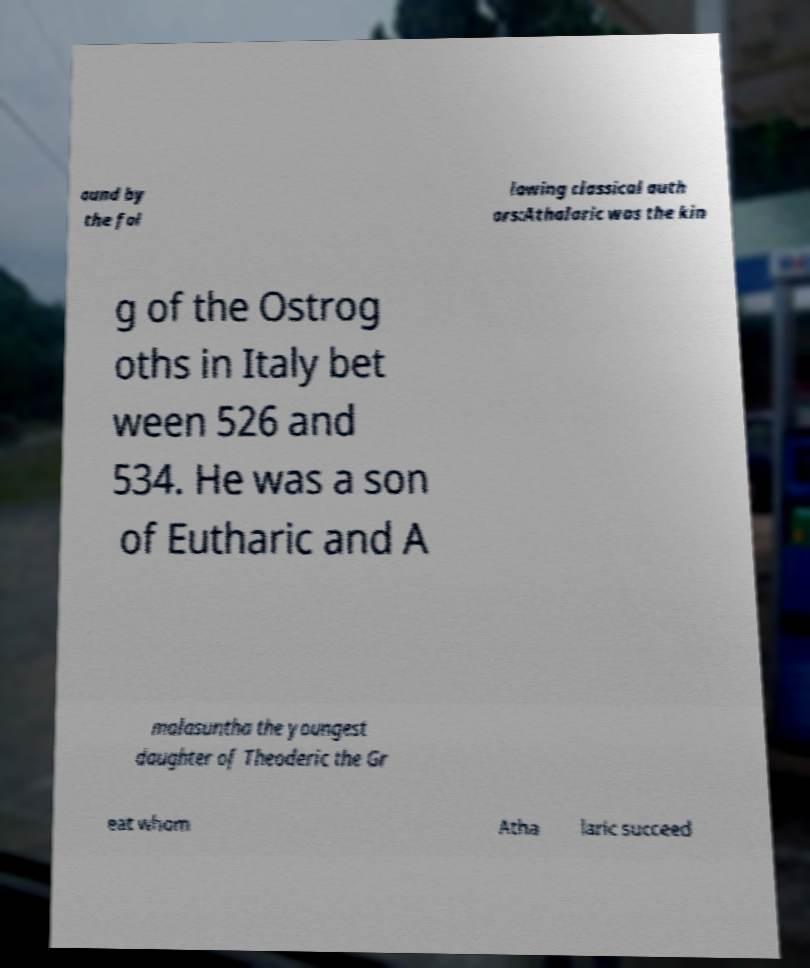For documentation purposes, I need the text within this image transcribed. Could you provide that? ound by the fol lowing classical auth ors:Athalaric was the kin g of the Ostrog oths in Italy bet ween 526 and 534. He was a son of Eutharic and A malasuntha the youngest daughter of Theoderic the Gr eat whom Atha laric succeed 